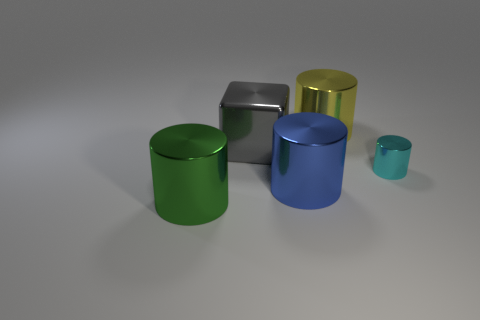What shape is the small object?
Make the answer very short. Cylinder. Is there a big gray cube that has the same material as the small cyan object?
Your response must be concise. Yes. Are there more big blue things than big cyan rubber cubes?
Make the answer very short. Yes. What number of rubber objects are either cyan objects or brown cubes?
Make the answer very short. 0. What color is the metal cube that is the same size as the blue thing?
Your response must be concise. Gray. What number of large gray things are the same shape as the blue thing?
Your answer should be very brief. 0. What number of cylinders are yellow shiny objects or large blue things?
Provide a short and direct response. 2. Does the metallic thing in front of the blue cylinder have the same shape as the object on the right side of the large yellow cylinder?
Give a very brief answer. Yes. How many cyan metal cylinders are the same size as the gray block?
Offer a very short reply. 0. How many objects are either big cylinders to the right of the large green thing or cylinders in front of the gray thing?
Your answer should be very brief. 4. 